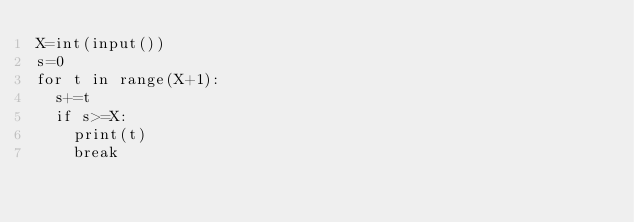<code> <loc_0><loc_0><loc_500><loc_500><_Python_>X=int(input())
s=0
for t in range(X+1):
  s+=t
  if s>=X:
    print(t)
    break</code> 